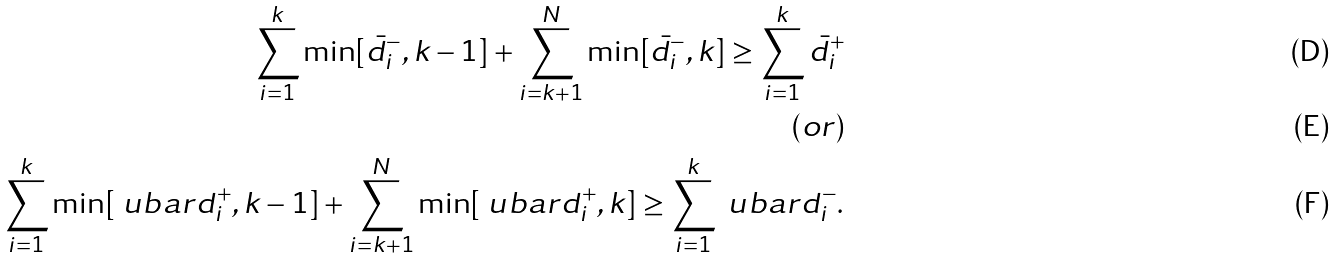<formula> <loc_0><loc_0><loc_500><loc_500>\sum _ { i = 1 } ^ { k } \min [ \bar { d } ^ { - } _ { i } , k - 1 ] + \sum _ { i = k + 1 } ^ { N } \min [ \bar { d } ^ { - } _ { i } , k ] \geq \sum _ { i = 1 } ^ { k } \bar { d } ^ { + } _ { i } \\ ( o r ) \\ \sum _ { i = 1 } ^ { k } \min [ \ u b a r { d } ^ { + } _ { i } , k - 1 ] + \sum _ { i = k + 1 } ^ { N } \min [ \ u b a r { d } ^ { + } _ { i } , k ] \geq \sum _ { i = 1 } ^ { k } \ u b a r { d } ^ { - } _ { i } .</formula> 